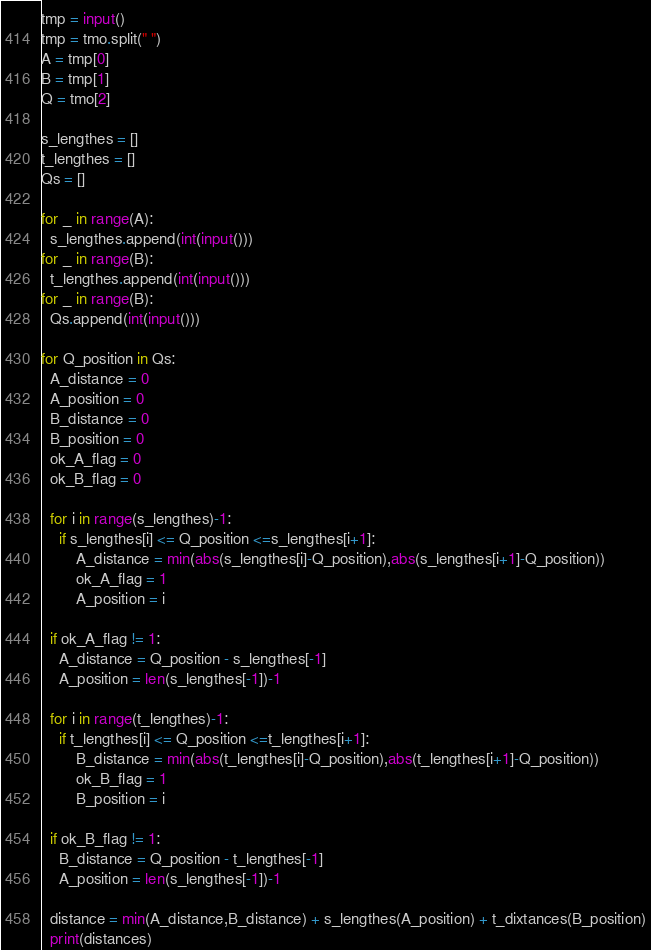<code> <loc_0><loc_0><loc_500><loc_500><_Python_>tmp = input()
tmp = tmo.split(" ")
A = tmp[0]
B = tmp[1]
Q = tmo[2]

s_lengthes = []
t_lengthes = []
Qs = []

for _ in range(A):
  s_lengthes.append(int(input()))
for _ in range(B):
  t_lengthes.append(int(input()))
for _ in range(B):
  Qs.append(int(input()))

for Q_position in Qs:
  A_distance = 0
  A_position = 0
  B_distance = 0
  B_position = 0
  ok_A_flag = 0
  ok_B_flag = 0
  
  for i in range(s_lengthes)-1:
    if s_lengthes[i] <= Q_position <=s_lengthes[i+1]:
    	A_distance = min(abs(s_lengthes[i]-Q_position),abs(s_lengthes[i+1]-Q_position))
        ok_A_flag = 1
        A_position = i
                         
  if ok_A_flag != 1:
    A_distance = Q_position - s_lengthes[-1]
    A_position = len(s_lengthes[-1])-1
    
  for i in range(t_lengthes)-1:
    if t_lengthes[i] <= Q_position <=t_lengthes[i+1]:
    	B_distance = min(abs(t_lengthes[i]-Q_position),abs(t_lengthes[i+1]-Q_position))
        ok_B_flag = 1
        B_position = i 
        
  if ok_B_flag != 1:
    B_distance = Q_position - t_lengthes[-1]
    A_position = len(s_lengthes[-1])-1
    
  distance = min(A_distance,B_distance) + s_lengthes(A_position) + t_dixtances(B_position)
  print(distances)</code> 